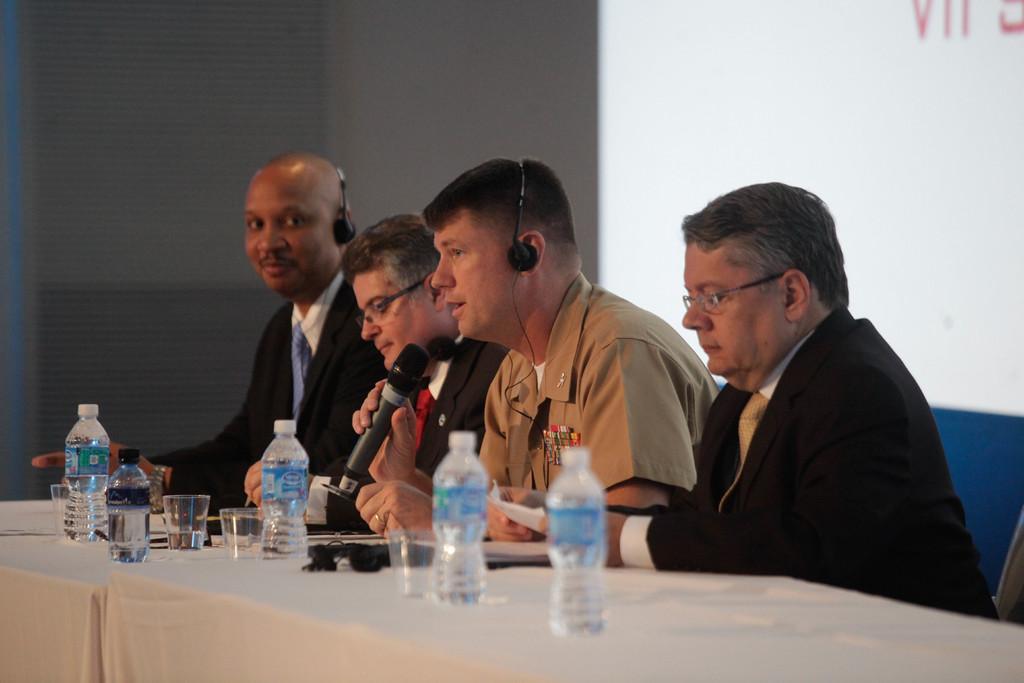In one or two sentences, can you explain what this image depicts? In this image in the center there are some persons sitting and two of them are wearing headsets, and one person is holding a mike and talking. In front of them there is a table, on the table there are some bottles, glasses, wires and some objects. In the background there is a wall and screen. 